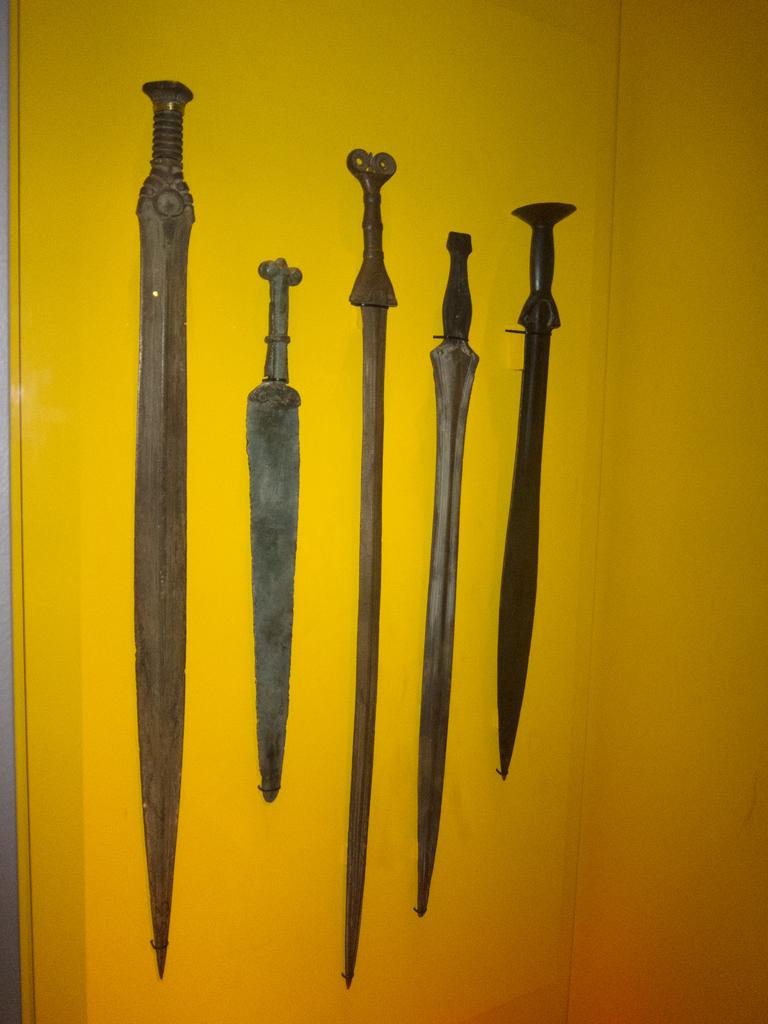How many swords are hanging on the wall in the image? There are five swords on the wall in the image. What type of home decoration is made of icicles in the image? There are no icicles present in the image, and therefore no such decoration can be observed. 